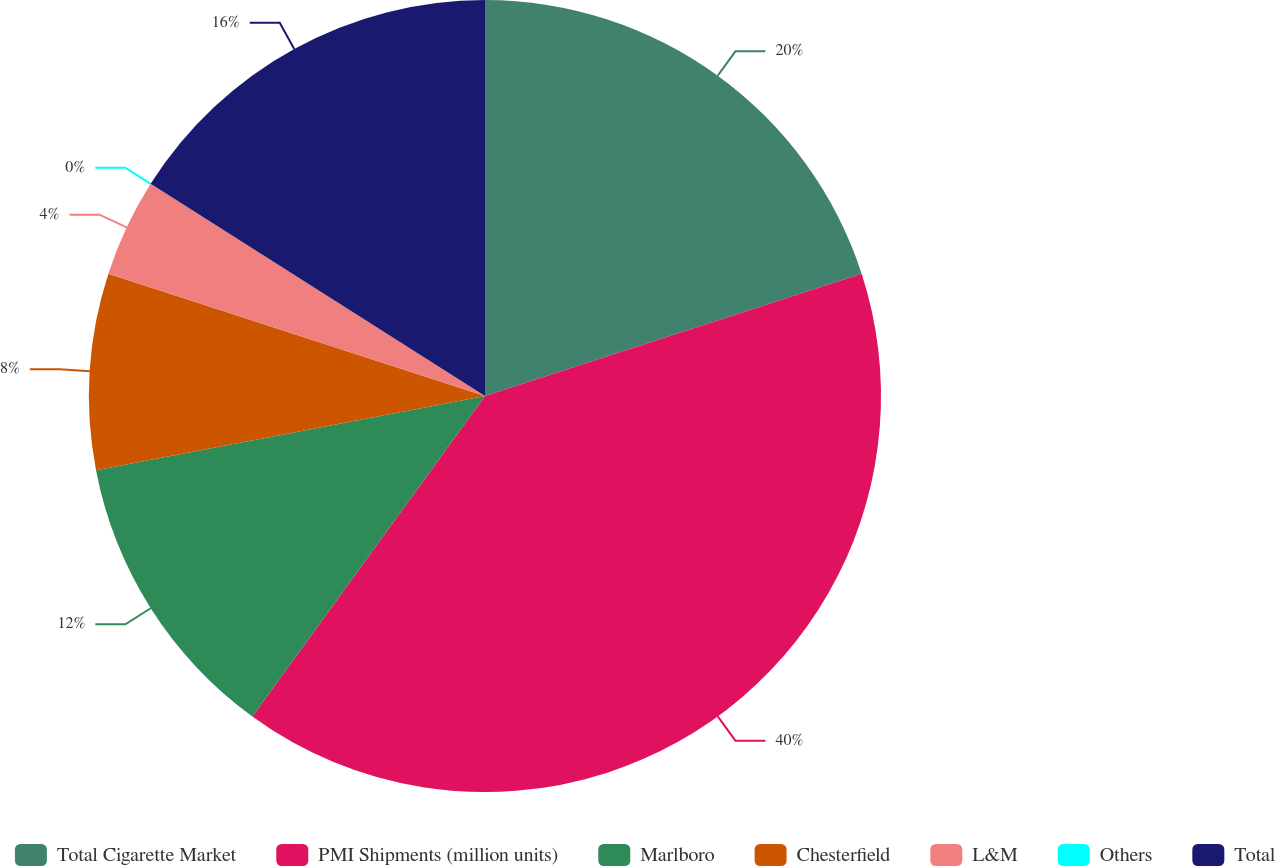<chart> <loc_0><loc_0><loc_500><loc_500><pie_chart><fcel>Total Cigarette Market<fcel>PMI Shipments (million units)<fcel>Marlboro<fcel>Chesterfield<fcel>L&M<fcel>Others<fcel>Total<nl><fcel>20.0%<fcel>39.99%<fcel>12.0%<fcel>8.0%<fcel>4.0%<fcel>0.0%<fcel>16.0%<nl></chart> 